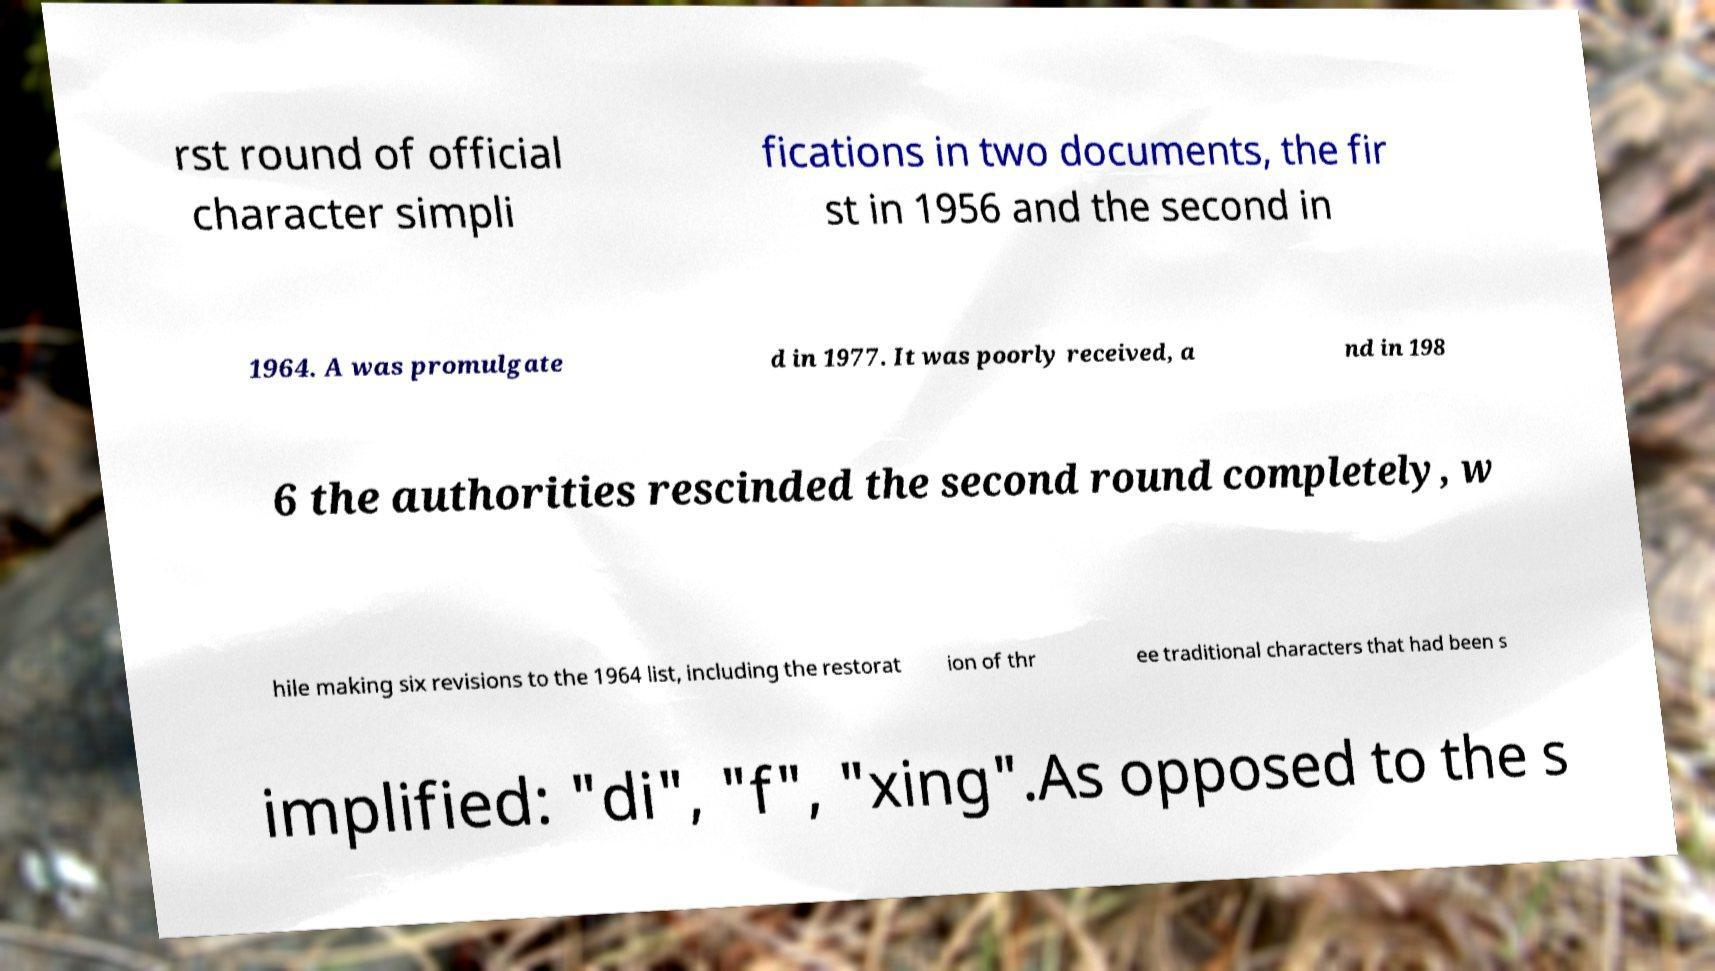I need the written content from this picture converted into text. Can you do that? rst round of official character simpli fications in two documents, the fir st in 1956 and the second in 1964. A was promulgate d in 1977. It was poorly received, a nd in 198 6 the authorities rescinded the second round completely, w hile making six revisions to the 1964 list, including the restorat ion of thr ee traditional characters that had been s implified: "di", "f", "xing".As opposed to the s 